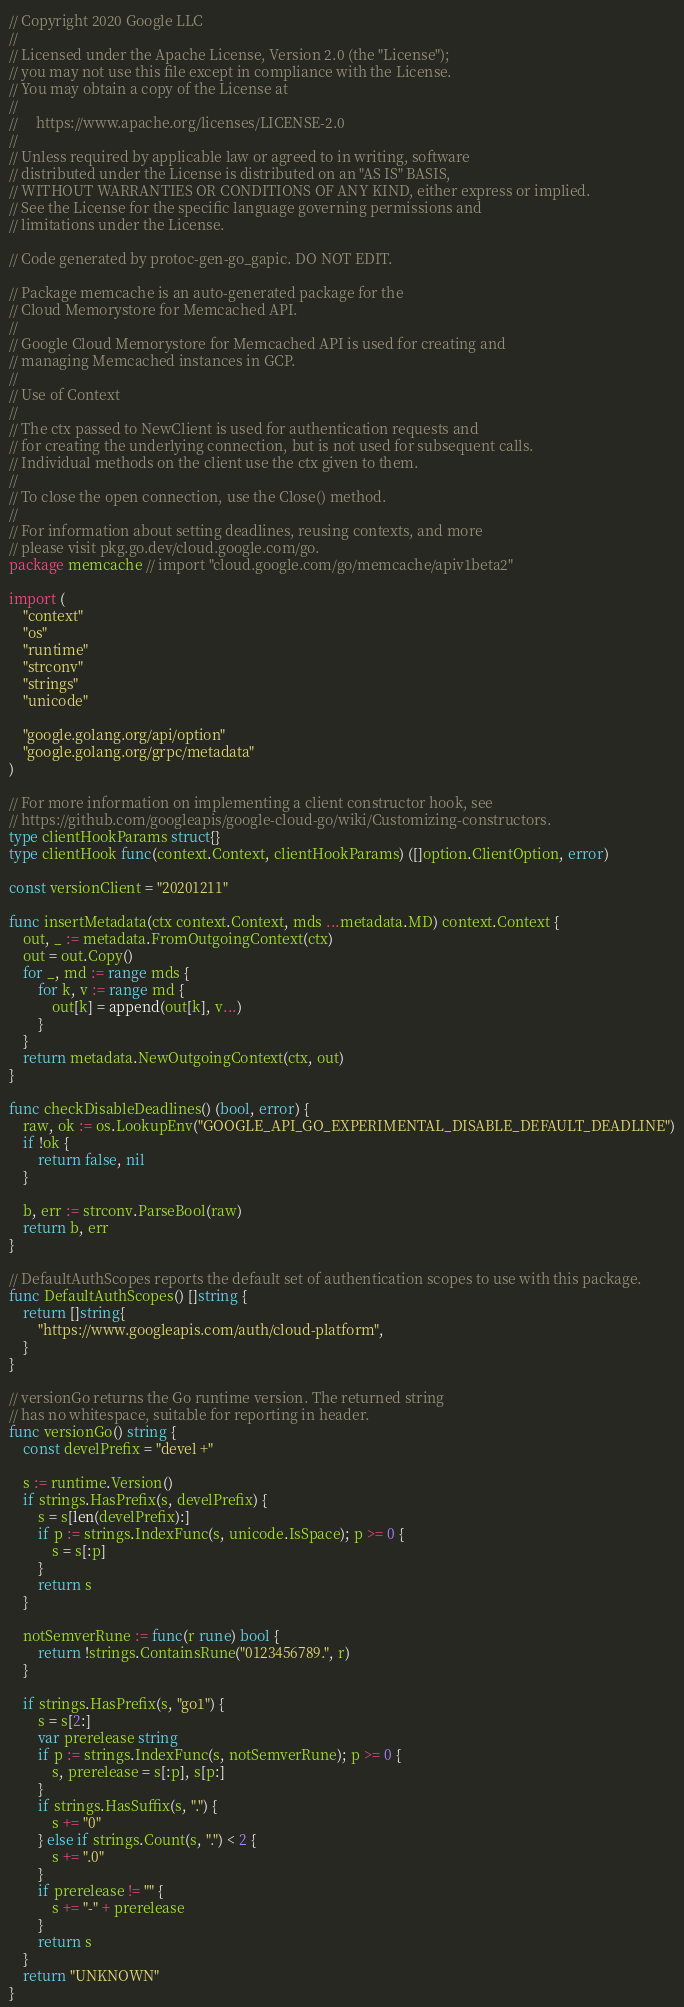Convert code to text. <code><loc_0><loc_0><loc_500><loc_500><_Go_>// Copyright 2020 Google LLC
//
// Licensed under the Apache License, Version 2.0 (the "License");
// you may not use this file except in compliance with the License.
// You may obtain a copy of the License at
//
//     https://www.apache.org/licenses/LICENSE-2.0
//
// Unless required by applicable law or agreed to in writing, software
// distributed under the License is distributed on an "AS IS" BASIS,
// WITHOUT WARRANTIES OR CONDITIONS OF ANY KIND, either express or implied.
// See the License for the specific language governing permissions and
// limitations under the License.

// Code generated by protoc-gen-go_gapic. DO NOT EDIT.

// Package memcache is an auto-generated package for the
// Cloud Memorystore for Memcached API.
//
// Google Cloud Memorystore for Memcached API is used for creating and
// managing Memcached instances in GCP.
//
// Use of Context
//
// The ctx passed to NewClient is used for authentication requests and
// for creating the underlying connection, but is not used for subsequent calls.
// Individual methods on the client use the ctx given to them.
//
// To close the open connection, use the Close() method.
//
// For information about setting deadlines, reusing contexts, and more
// please visit pkg.go.dev/cloud.google.com/go.
package memcache // import "cloud.google.com/go/memcache/apiv1beta2"

import (
	"context"
	"os"
	"runtime"
	"strconv"
	"strings"
	"unicode"

	"google.golang.org/api/option"
	"google.golang.org/grpc/metadata"
)

// For more information on implementing a client constructor hook, see
// https://github.com/googleapis/google-cloud-go/wiki/Customizing-constructors.
type clientHookParams struct{}
type clientHook func(context.Context, clientHookParams) ([]option.ClientOption, error)

const versionClient = "20201211"

func insertMetadata(ctx context.Context, mds ...metadata.MD) context.Context {
	out, _ := metadata.FromOutgoingContext(ctx)
	out = out.Copy()
	for _, md := range mds {
		for k, v := range md {
			out[k] = append(out[k], v...)
		}
	}
	return metadata.NewOutgoingContext(ctx, out)
}

func checkDisableDeadlines() (bool, error) {
	raw, ok := os.LookupEnv("GOOGLE_API_GO_EXPERIMENTAL_DISABLE_DEFAULT_DEADLINE")
	if !ok {
		return false, nil
	}

	b, err := strconv.ParseBool(raw)
	return b, err
}

// DefaultAuthScopes reports the default set of authentication scopes to use with this package.
func DefaultAuthScopes() []string {
	return []string{
		"https://www.googleapis.com/auth/cloud-platform",
	}
}

// versionGo returns the Go runtime version. The returned string
// has no whitespace, suitable for reporting in header.
func versionGo() string {
	const develPrefix = "devel +"

	s := runtime.Version()
	if strings.HasPrefix(s, develPrefix) {
		s = s[len(develPrefix):]
		if p := strings.IndexFunc(s, unicode.IsSpace); p >= 0 {
			s = s[:p]
		}
		return s
	}

	notSemverRune := func(r rune) bool {
		return !strings.ContainsRune("0123456789.", r)
	}

	if strings.HasPrefix(s, "go1") {
		s = s[2:]
		var prerelease string
		if p := strings.IndexFunc(s, notSemverRune); p >= 0 {
			s, prerelease = s[:p], s[p:]
		}
		if strings.HasSuffix(s, ".") {
			s += "0"
		} else if strings.Count(s, ".") < 2 {
			s += ".0"
		}
		if prerelease != "" {
			s += "-" + prerelease
		}
		return s
	}
	return "UNKNOWN"
}
</code> 